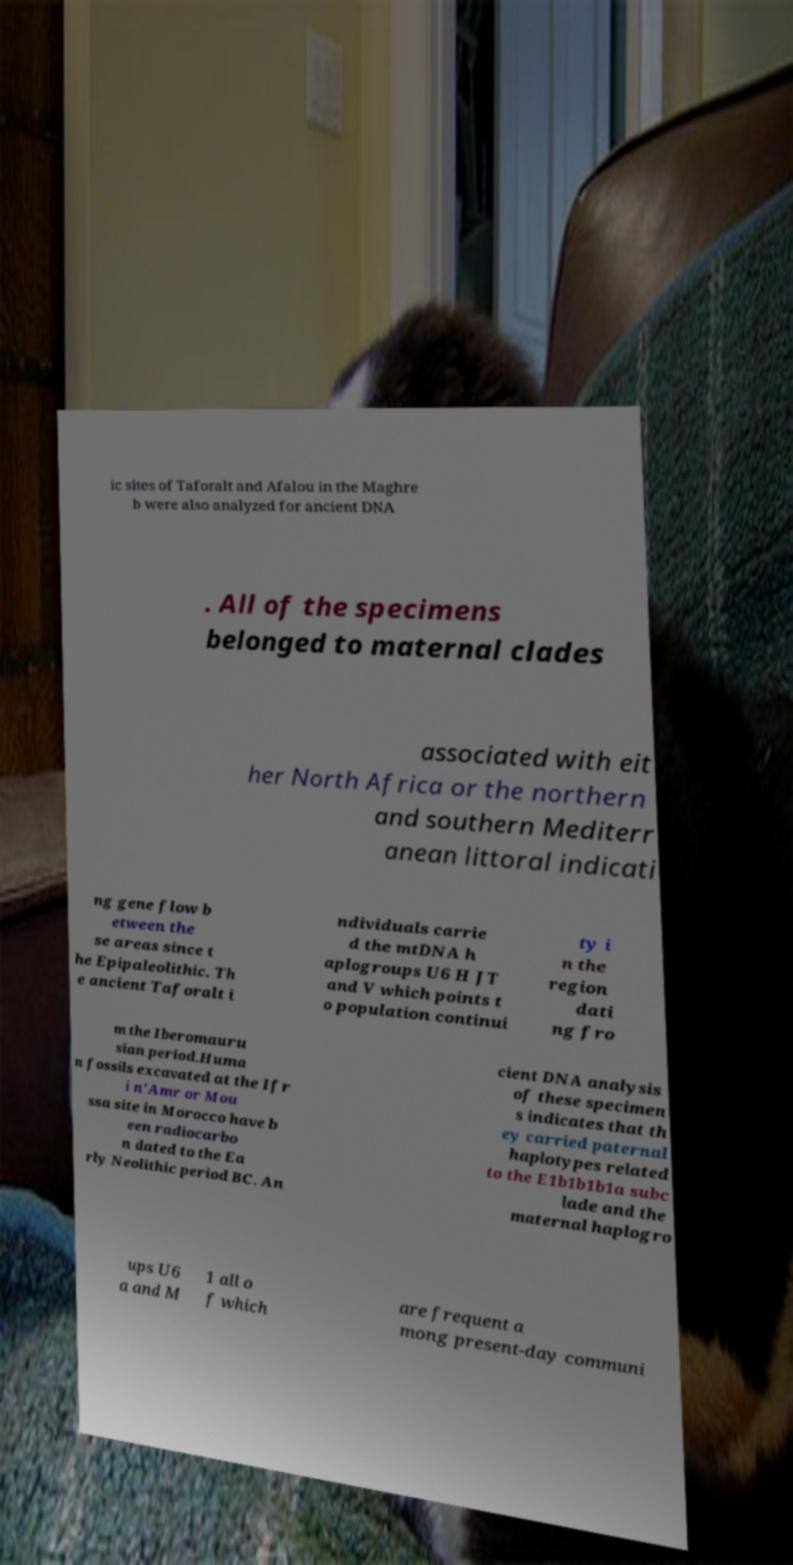For documentation purposes, I need the text within this image transcribed. Could you provide that? ic sites of Taforalt and Afalou in the Maghre b were also analyzed for ancient DNA . All of the specimens belonged to maternal clades associated with eit her North Africa or the northern and southern Mediterr anean littoral indicati ng gene flow b etween the se areas since t he Epipaleolithic. Th e ancient Taforalt i ndividuals carrie d the mtDNA h aplogroups U6 H JT and V which points t o population continui ty i n the region dati ng fro m the Iberomauru sian period.Huma n fossils excavated at the Ifr i n'Amr or Mou ssa site in Morocco have b een radiocarbo n dated to the Ea rly Neolithic period BC. An cient DNA analysis of these specimen s indicates that th ey carried paternal haplotypes related to the E1b1b1b1a subc lade and the maternal haplogro ups U6 a and M 1 all o f which are frequent a mong present-day communi 